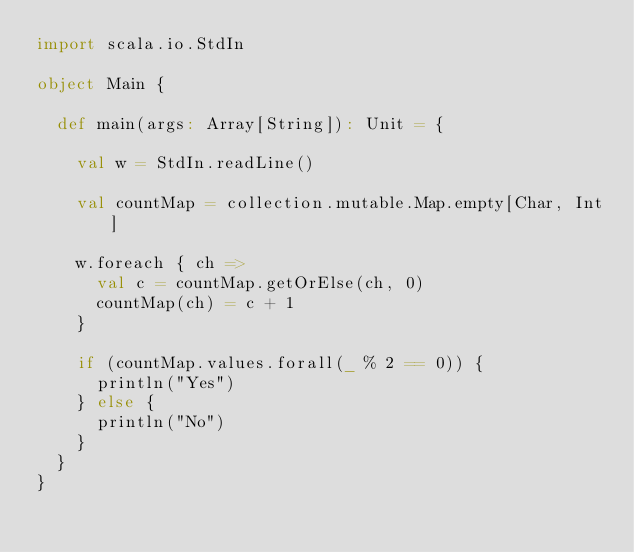Convert code to text. <code><loc_0><loc_0><loc_500><loc_500><_Scala_>import scala.io.StdIn

object Main {

  def main(args: Array[String]): Unit = {

    val w = StdIn.readLine()
    
    val countMap = collection.mutable.Map.empty[Char, Int]
    
    w.foreach { ch =>
      val c = countMap.getOrElse(ch, 0)
      countMap(ch) = c + 1
    }
    
    if (countMap.values.forall(_ % 2 == 0)) {
      println("Yes")
    } else {
      println("No")
    }
  }
}</code> 